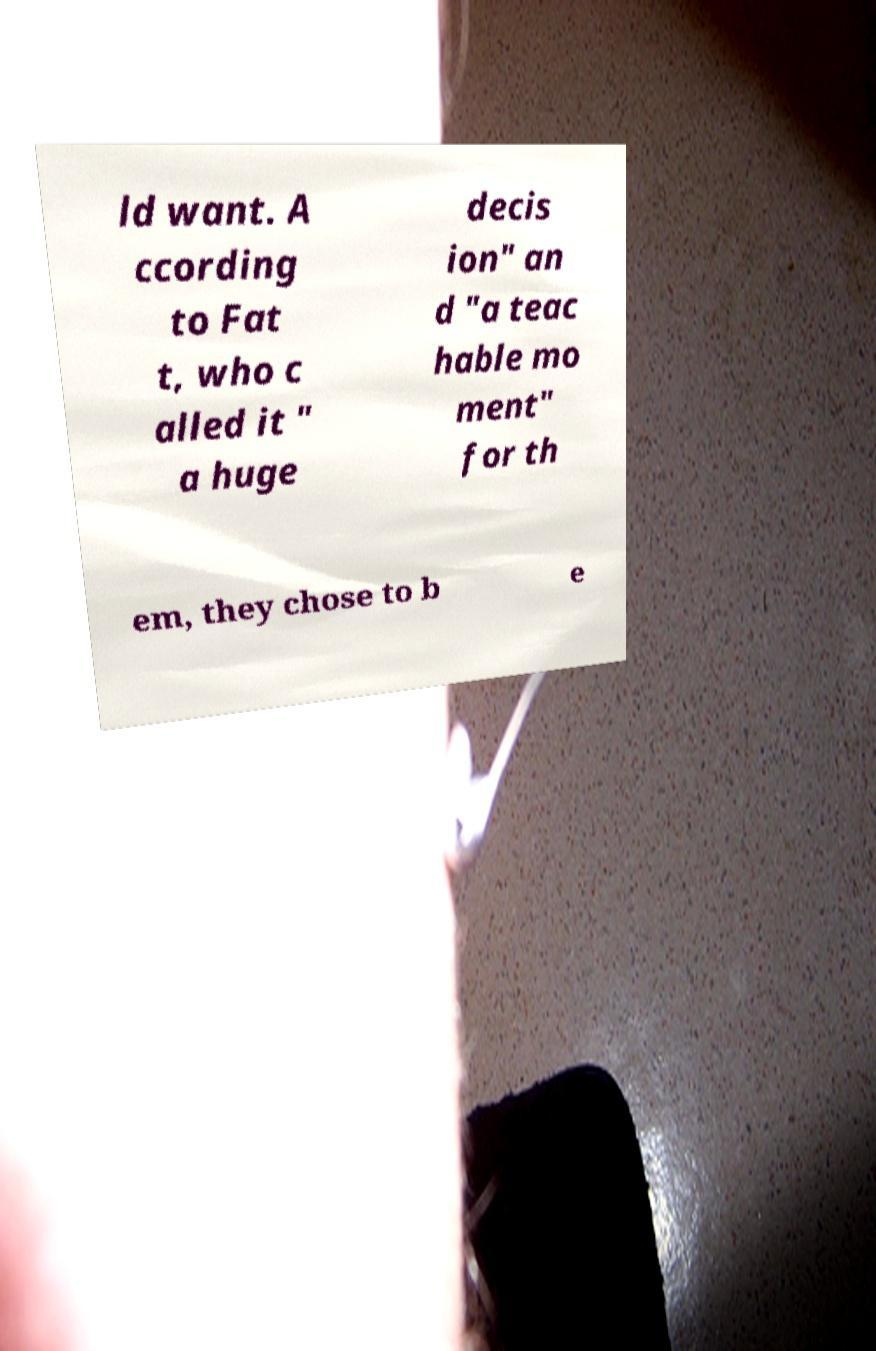What messages or text are displayed in this image? I need them in a readable, typed format. ld want. A ccording to Fat t, who c alled it " a huge decis ion" an d "a teac hable mo ment" for th em, they chose to b e 